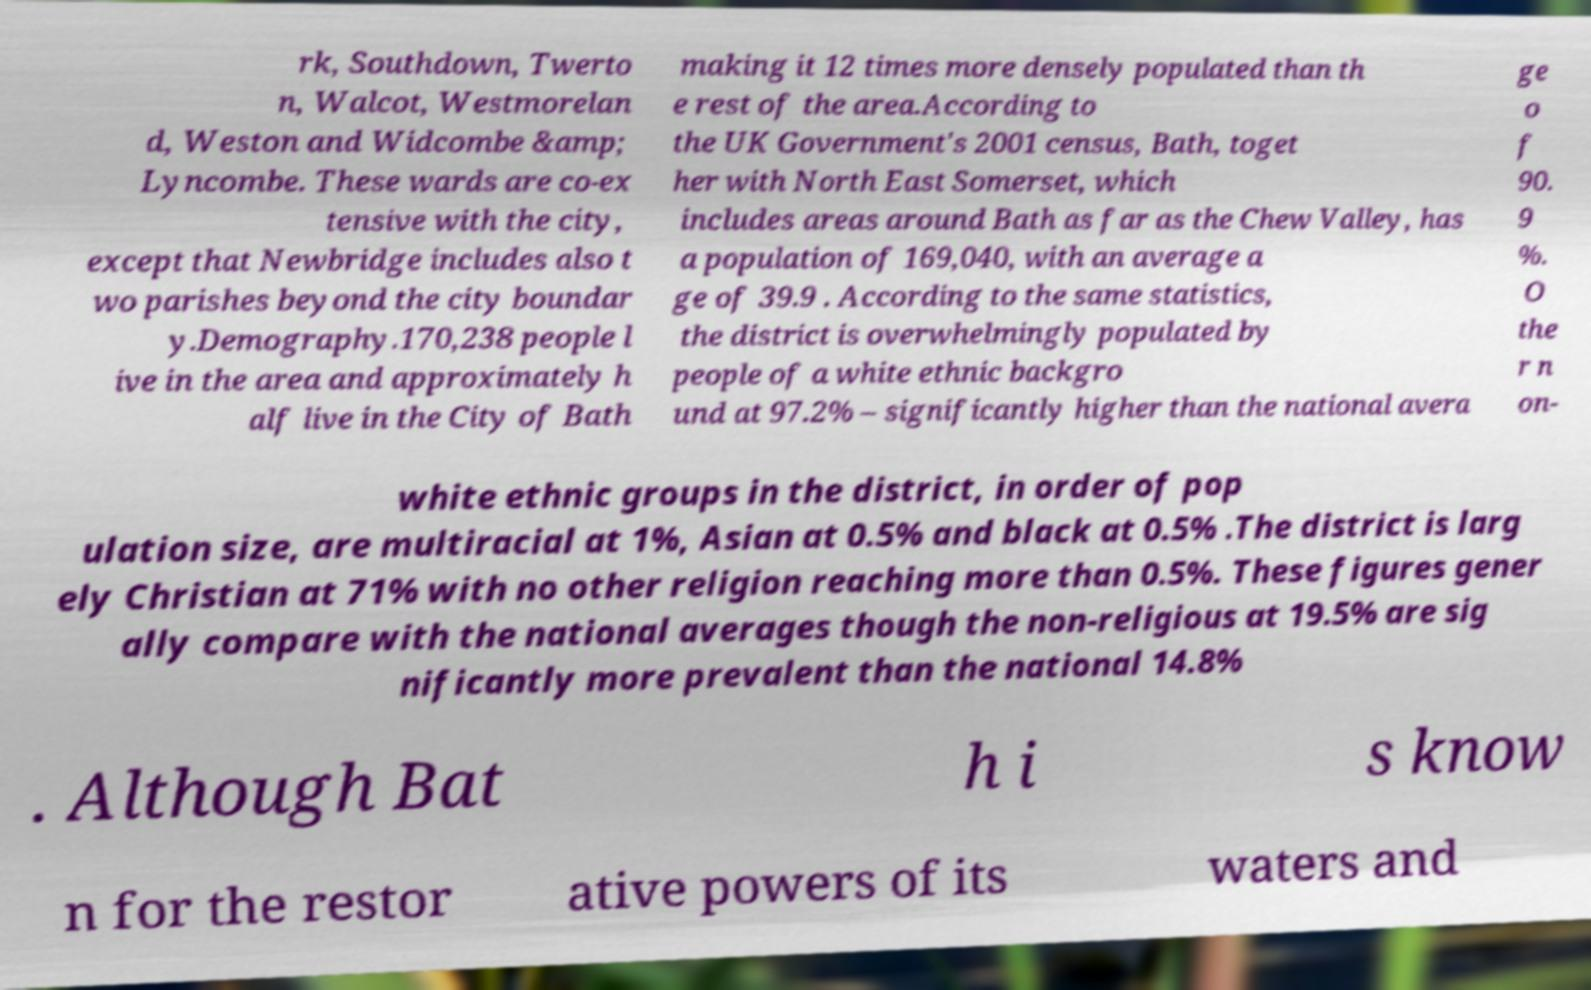Please read and relay the text visible in this image. What does it say? rk, Southdown, Twerto n, Walcot, Westmorelan d, Weston and Widcombe &amp; Lyncombe. These wards are co-ex tensive with the city, except that Newbridge includes also t wo parishes beyond the city boundar y.Demography.170,238 people l ive in the area and approximately h alf live in the City of Bath making it 12 times more densely populated than th e rest of the area.According to the UK Government's 2001 census, Bath, toget her with North East Somerset, which includes areas around Bath as far as the Chew Valley, has a population of 169,040, with an average a ge of 39.9 . According to the same statistics, the district is overwhelmingly populated by people of a white ethnic backgro und at 97.2% – significantly higher than the national avera ge o f 90. 9 %. O the r n on- white ethnic groups in the district, in order of pop ulation size, are multiracial at 1%, Asian at 0.5% and black at 0.5% .The district is larg ely Christian at 71% with no other religion reaching more than 0.5%. These figures gener ally compare with the national averages though the non-religious at 19.5% are sig nificantly more prevalent than the national 14.8% . Although Bat h i s know n for the restor ative powers of its waters and 